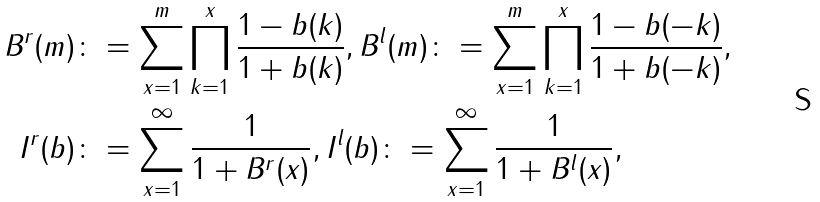Convert formula to latex. <formula><loc_0><loc_0><loc_500><loc_500>B ^ { r } ( m ) & \colon = \sum _ { x = 1 } ^ { m } \prod _ { k = 1 } ^ { x } \frac { 1 - b ( k ) } { 1 + b ( k ) } , B ^ { l } ( m ) \colon = \sum _ { x = 1 } ^ { m } \prod _ { k = 1 } ^ { x } \frac { 1 - b ( - k ) } { 1 + b ( - k ) } , \\ I ^ { r } ( b ) & \colon = \sum _ { x = 1 } ^ { \infty } \frac { 1 } { 1 + B ^ { r } ( x ) } , I ^ { l } ( b ) \colon = \sum _ { x = 1 } ^ { \infty } \frac { 1 } { 1 + B ^ { l } ( x ) } ,</formula> 